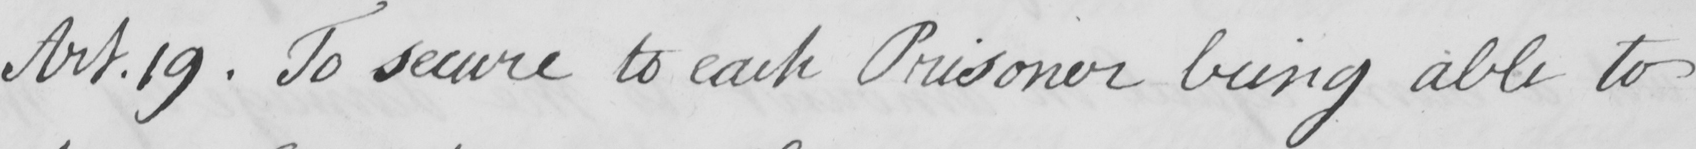Can you tell me what this handwritten text says? Art . 19 . To secure to each Prisoner being able to 